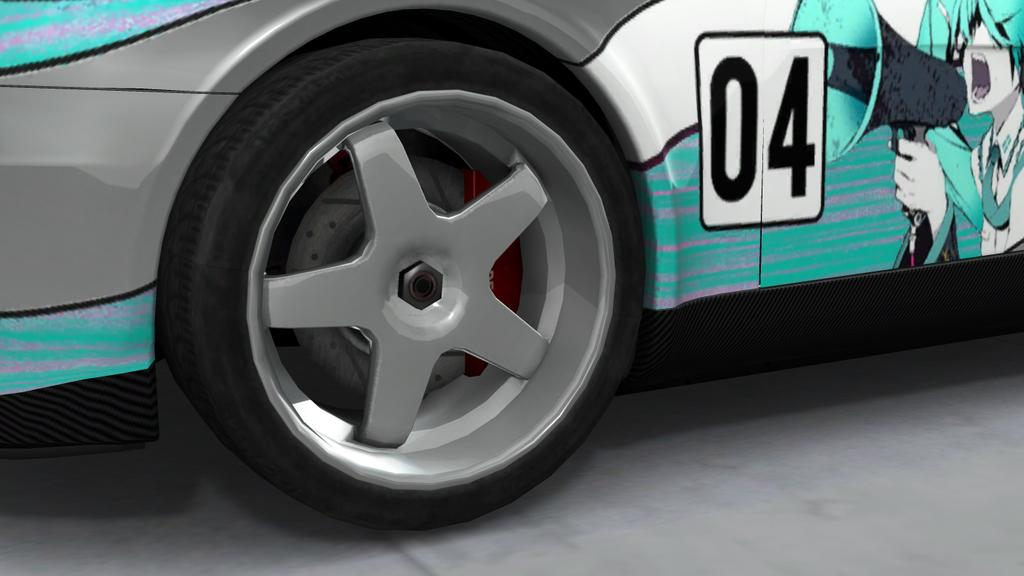What is the main subject of the image? There is a car in the image. What type of quill is being used to write on the car in the image? There is no quill present in the image, and the car is not being used for writing. 